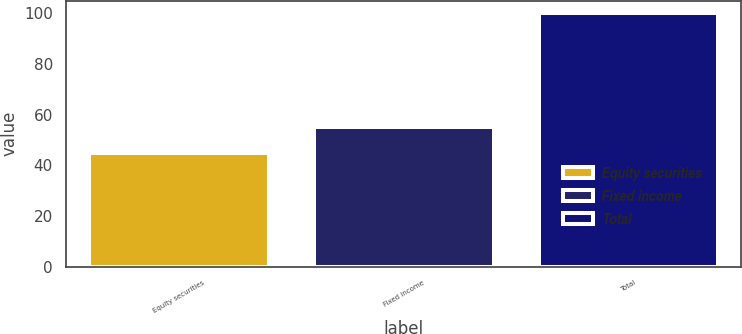Convert chart. <chart><loc_0><loc_0><loc_500><loc_500><bar_chart><fcel>Equity securities<fcel>Fixed income<fcel>Total<nl><fcel>45<fcel>55<fcel>100<nl></chart> 